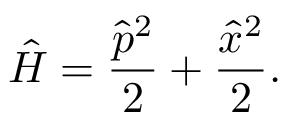Convert formula to latex. <formula><loc_0><loc_0><loc_500><loc_500>\hat { H } = \frac { \hat { p } ^ { 2 } } { 2 } + \frac { \hat { x } ^ { 2 } } { 2 } .</formula> 